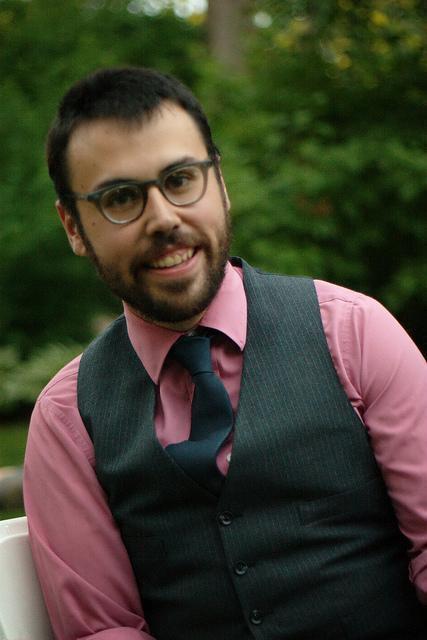Why is he smiling?
From the following four choices, select the correct answer to address the question.
Options: Is surprised, for camera, won money, is friendly. For camera. 